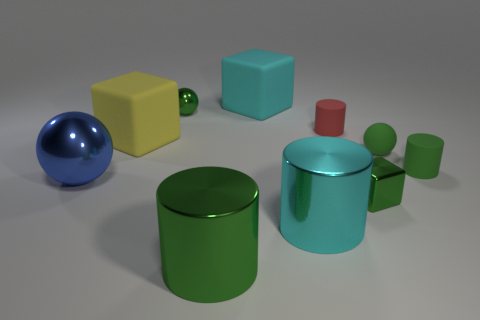What number of other objects are there of the same color as the large sphere? Upon reviewing the image, there are no other objects of the same shiny deep blue color as the large sphere. However, it is important to consider that perception of color can vary slightly based on lighting and reflections. 